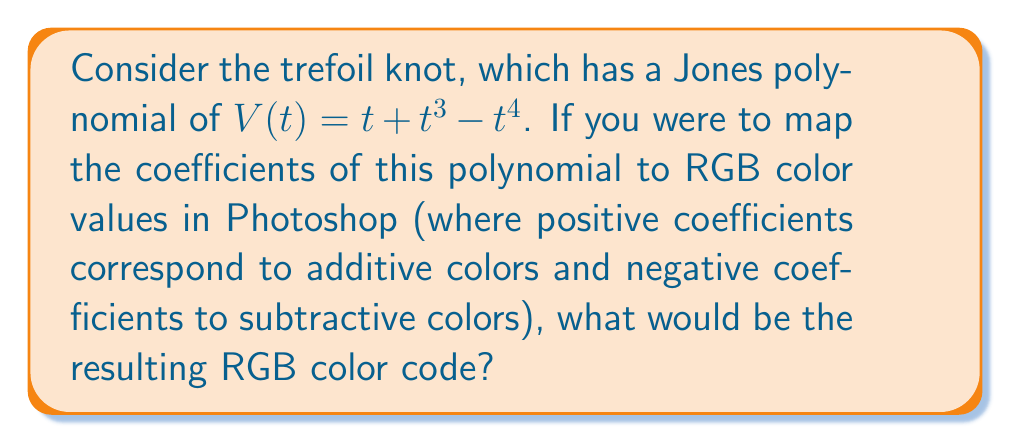Could you help me with this problem? Let's approach this step-by-step:

1) The Jones polynomial of the trefoil knot is $V(t) = t + t^3 - t^4$

2) We need to map the coefficients to RGB values:
   R: $t^1$ coefficient = 1
   G: $t^3$ coefficient = 1
   B: $t^4$ coefficient = -1

3) In Photoshop, RGB values range from 0 to 255. Let's map our coefficients to this range:
   Positive coefficients (1) → 255
   Negative coefficients (-1) → 0

4) Therefore, our RGB values are:
   R: 255
   G: 255
   B: 0

5) In Photoshop's color picker, this would be represented as #FFFF00

6) This color is a bright yellow, which could be an interesting starting point for abstract art based on the trefoil knot's Jones polynomial.
Answer: #FFFF00 